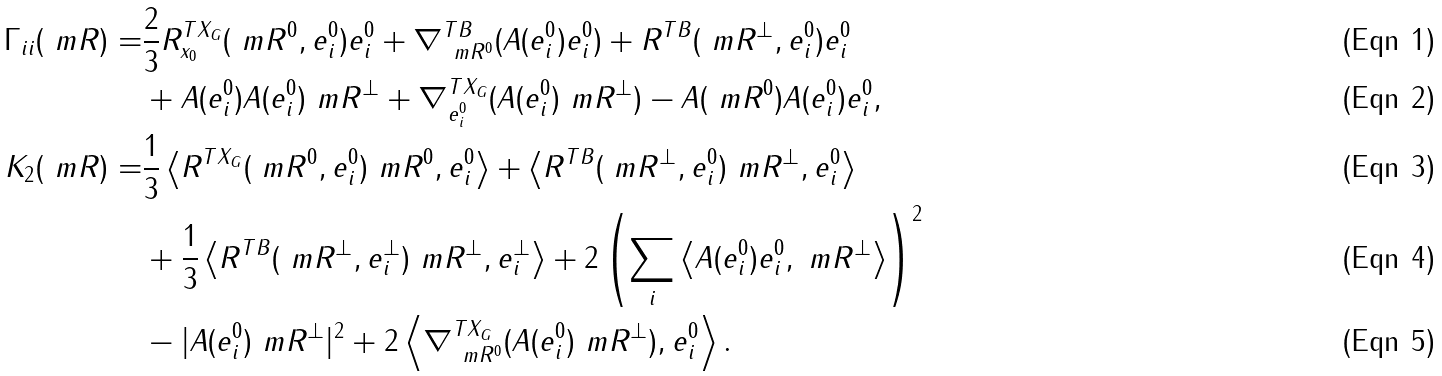<formula> <loc_0><loc_0><loc_500><loc_500>\Gamma _ { i i } ( \ m R ) = & \frac { 2 } { 3 } R ^ { T X _ { G } } _ { x _ { 0 } } ( \ m R ^ { 0 } , e ^ { 0 } _ { i } ) e ^ { 0 } _ { i } + \nabla ^ { T B } _ { \ m R ^ { 0 } } ( A ( e ^ { 0 } _ { i } ) e ^ { 0 } _ { i } ) + R ^ { T B } ( \ m R ^ { \bot } , e ^ { 0 } _ { i } ) e ^ { 0 } _ { i } \\ & + A ( e ^ { 0 } _ { i } ) A ( e ^ { 0 } _ { i } ) \ m R ^ { \bot } + \nabla ^ { T X _ { G } } _ { e ^ { 0 } _ { i } } ( A ( e ^ { 0 } _ { i } ) \ m R ^ { \bot } ) - A ( \ m R ^ { 0 } ) A ( e ^ { 0 } _ { i } ) e ^ { 0 } _ { i } , \\ K _ { 2 } ( \ m R ) = & \frac { 1 } { 3 } \left \langle R ^ { T X _ { G } } ( \ m R ^ { 0 } , e ^ { 0 } _ { i } ) \ m R ^ { 0 } , e ^ { 0 } _ { i } \right \rangle + \left \langle R ^ { T B } ( \ m R ^ { \bot } , e ^ { 0 } _ { i } ) \ m R ^ { \bot } , e ^ { 0 } _ { i } \right \rangle \\ & + \frac { 1 } { 3 } \left \langle R ^ { T B } ( \ m R ^ { \bot } , e ^ { \bot } _ { i } ) \ m R ^ { \bot } , e ^ { \bot } _ { i } \right \rangle + 2 \left ( \sum _ { i } \left \langle A ( e ^ { 0 } _ { i } ) e ^ { 0 } _ { i } , \ m R ^ { \bot } \right \rangle \right ) ^ { 2 } \\ & - | A ( e ^ { 0 } _ { i } ) \ m R ^ { \bot } | ^ { 2 } + 2 \left \langle \nabla ^ { T X _ { G } } _ { \ m R ^ { 0 } } ( A ( e ^ { 0 } _ { i } ) \ m R ^ { \bot } ) , e ^ { 0 } _ { i } \right \rangle .</formula> 